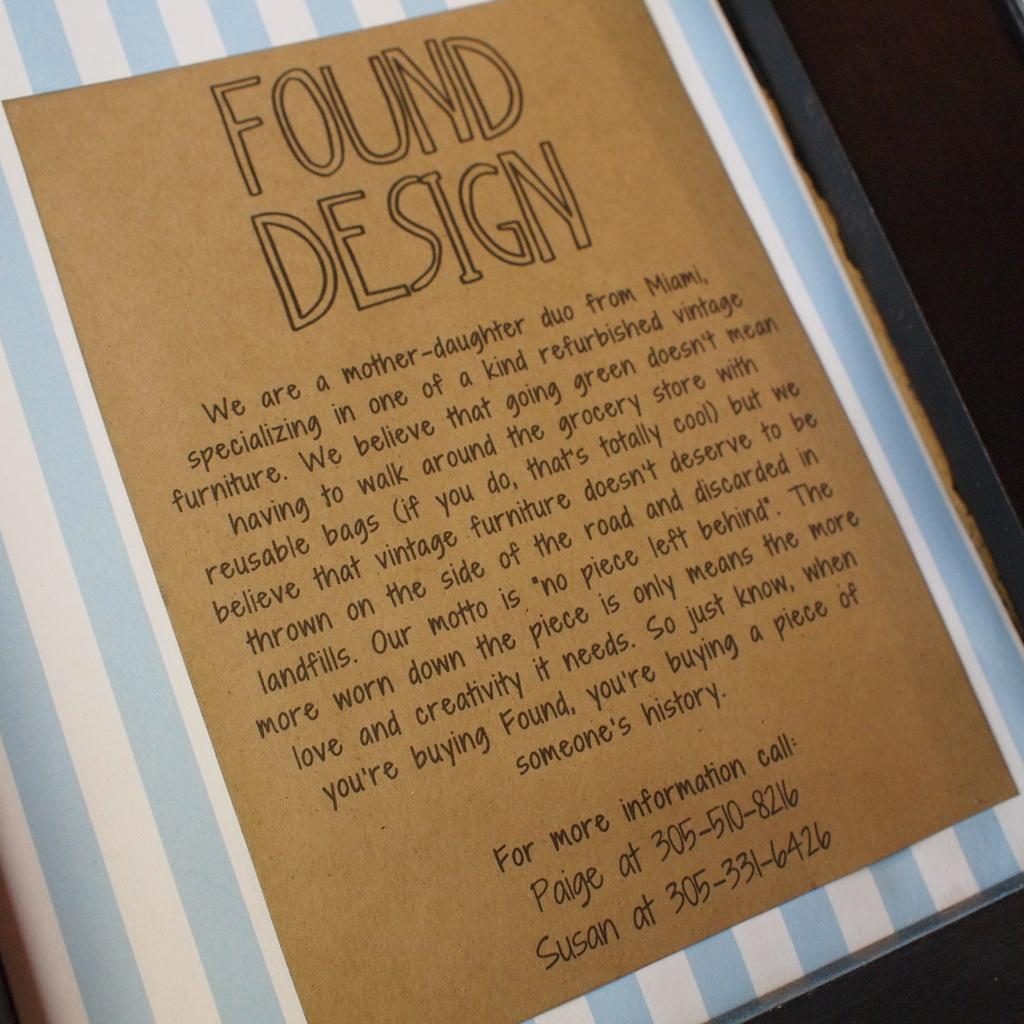<image>
Share a concise interpretation of the image provided. A mother-daughter business is described in a page titled Found Design. 